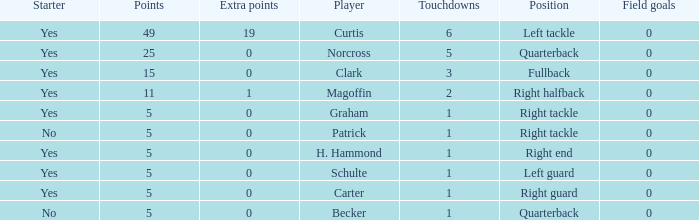Name the extra points for left guard 0.0. Parse the table in full. {'header': ['Starter', 'Points', 'Extra points', 'Player', 'Touchdowns', 'Position', 'Field goals'], 'rows': [['Yes', '49', '19', 'Curtis', '6', 'Left tackle', '0'], ['Yes', '25', '0', 'Norcross', '5', 'Quarterback', '0'], ['Yes', '15', '0', 'Clark', '3', 'Fullback', '0'], ['Yes', '11', '1', 'Magoffin', '2', 'Right halfback', '0'], ['Yes', '5', '0', 'Graham', '1', 'Right tackle', '0'], ['No', '5', '0', 'Patrick', '1', 'Right tackle', '0'], ['Yes', '5', '0', 'H. Hammond', '1', 'Right end', '0'], ['Yes', '5', '0', 'Schulte', '1', 'Left guard', '0'], ['Yes', '5', '0', 'Carter', '1', 'Right guard', '0'], ['No', '5', '0', 'Becker', '1', 'Quarterback', '0']]} 